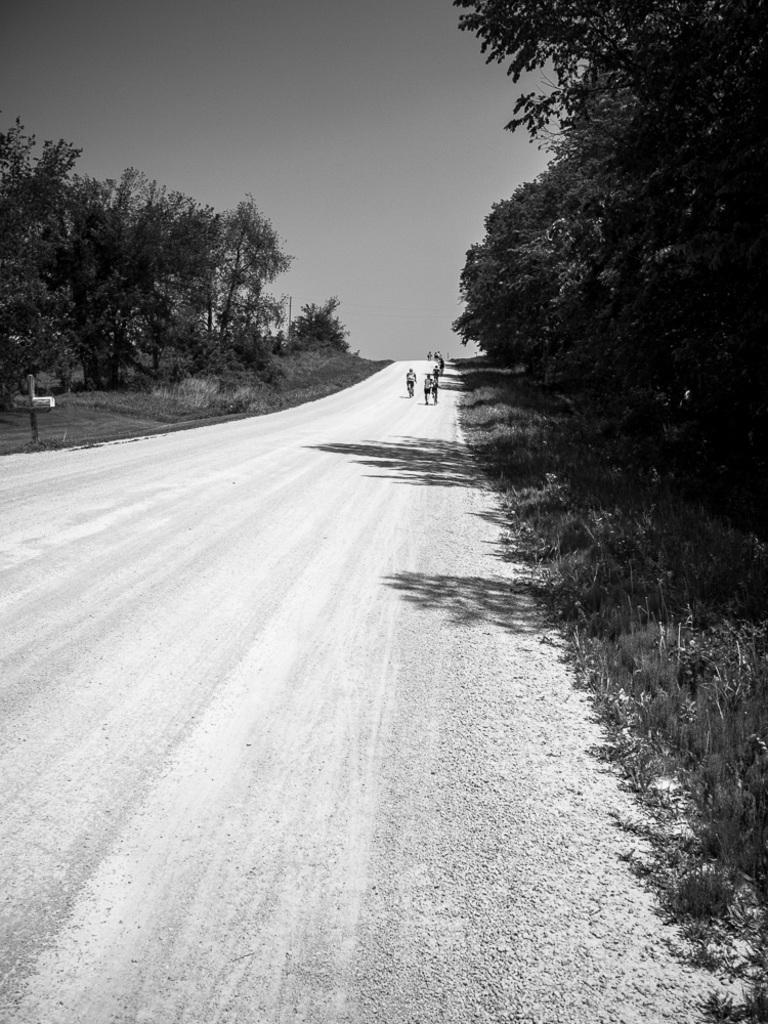How would you summarize this image in a sentence or two? This is a black and white image. In the center of the image we can see some people are riding their bicycles. In the background of the image we can see the trees, road. At the top of the image we can see the sky. 